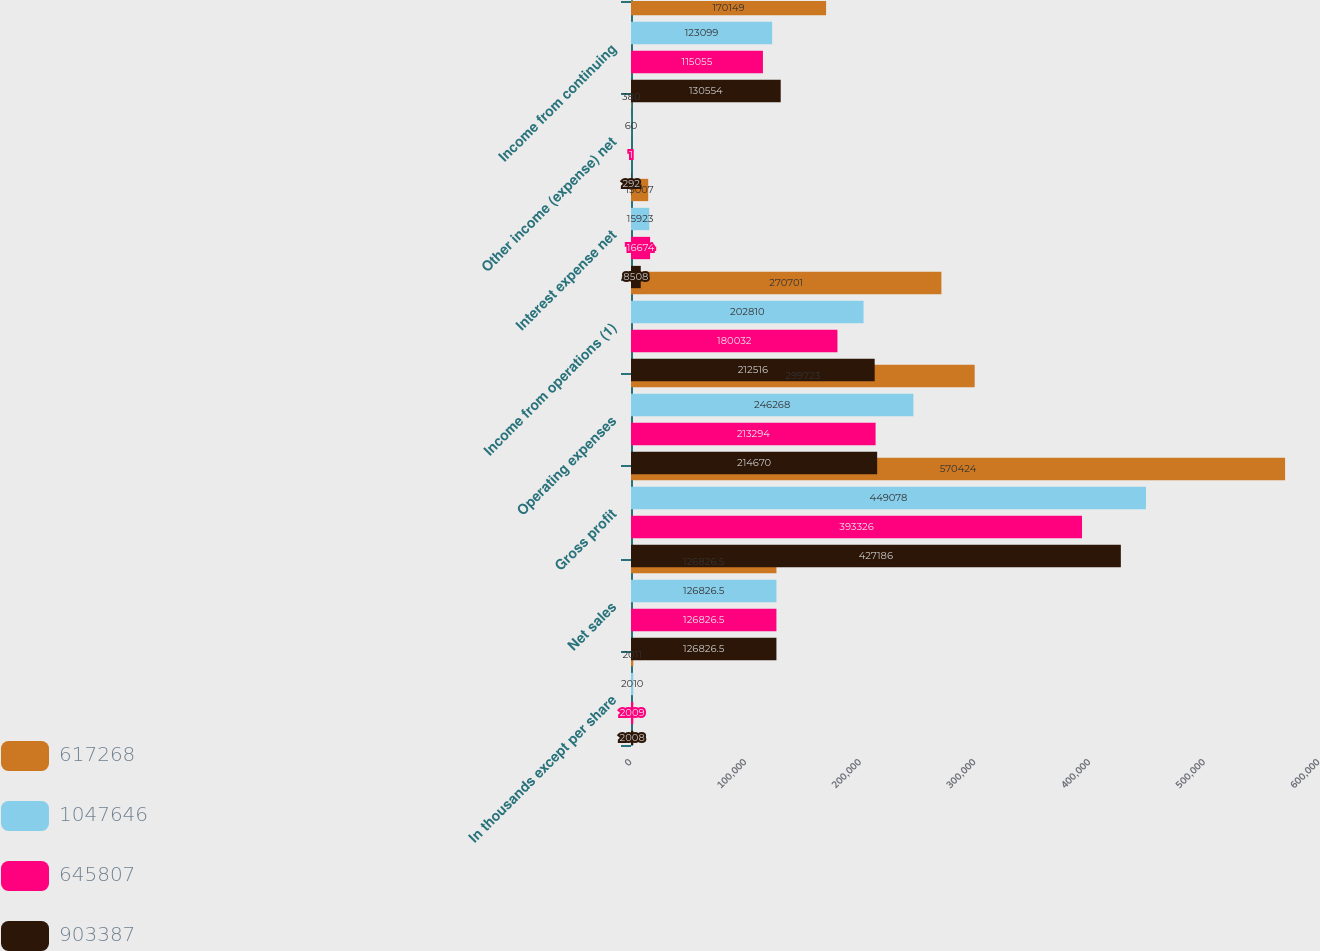Convert chart. <chart><loc_0><loc_0><loc_500><loc_500><stacked_bar_chart><ecel><fcel>In thousands except per share<fcel>Net sales<fcel>Gross profit<fcel>Operating expenses<fcel>Income from operations (1)<fcel>Interest expense net<fcel>Other income (expense) net<fcel>Income from continuing<nl><fcel>617268<fcel>2011<fcel>126826<fcel>570424<fcel>299723<fcel>270701<fcel>15007<fcel>380<fcel>170149<nl><fcel>1.04765e+06<fcel>2010<fcel>126826<fcel>449078<fcel>246268<fcel>202810<fcel>15923<fcel>60<fcel>123099<nl><fcel>645807<fcel>2009<fcel>126826<fcel>393326<fcel>213294<fcel>180032<fcel>16674<fcel>1<fcel>115055<nl><fcel>903387<fcel>2008<fcel>126826<fcel>427186<fcel>214670<fcel>212516<fcel>8508<fcel>292<fcel>130554<nl></chart> 